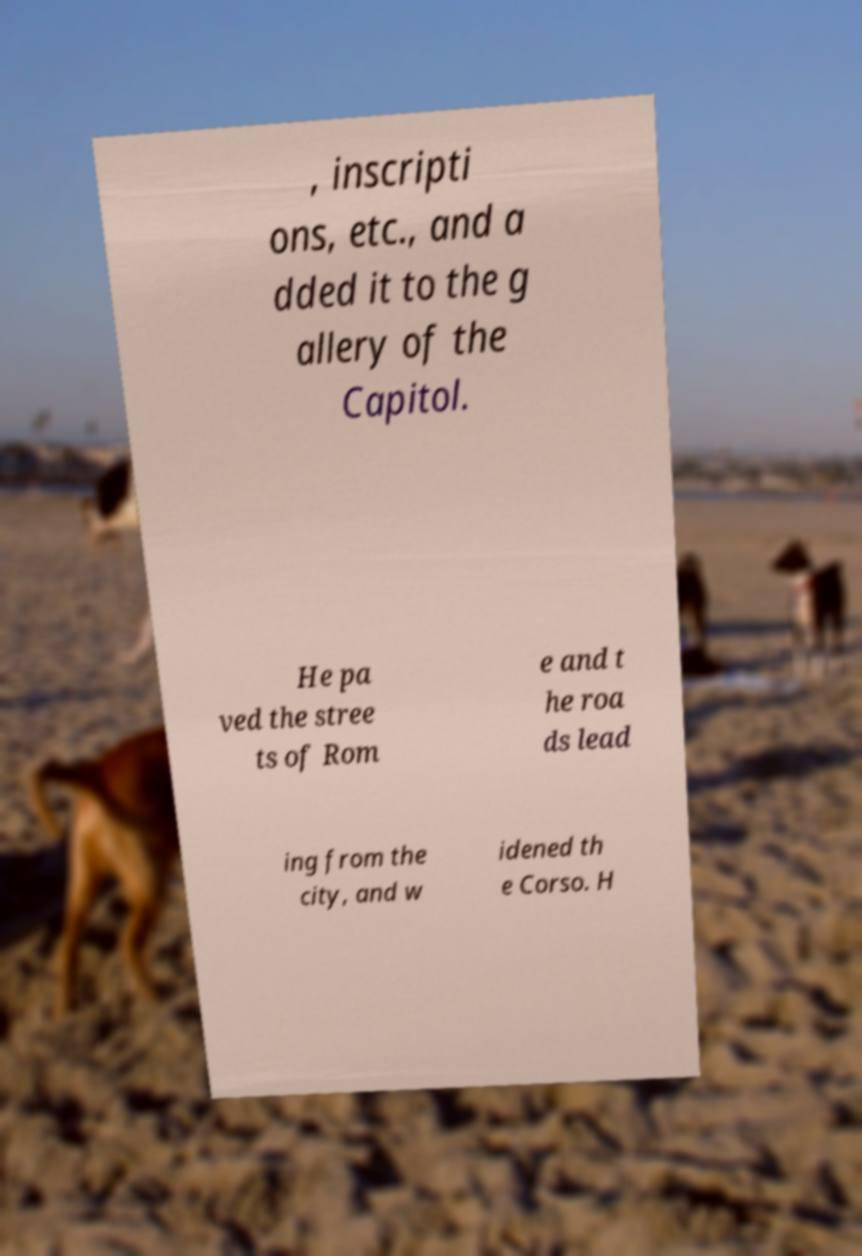Can you accurately transcribe the text from the provided image for me? , inscripti ons, etc., and a dded it to the g allery of the Capitol. He pa ved the stree ts of Rom e and t he roa ds lead ing from the city, and w idened th e Corso. H 